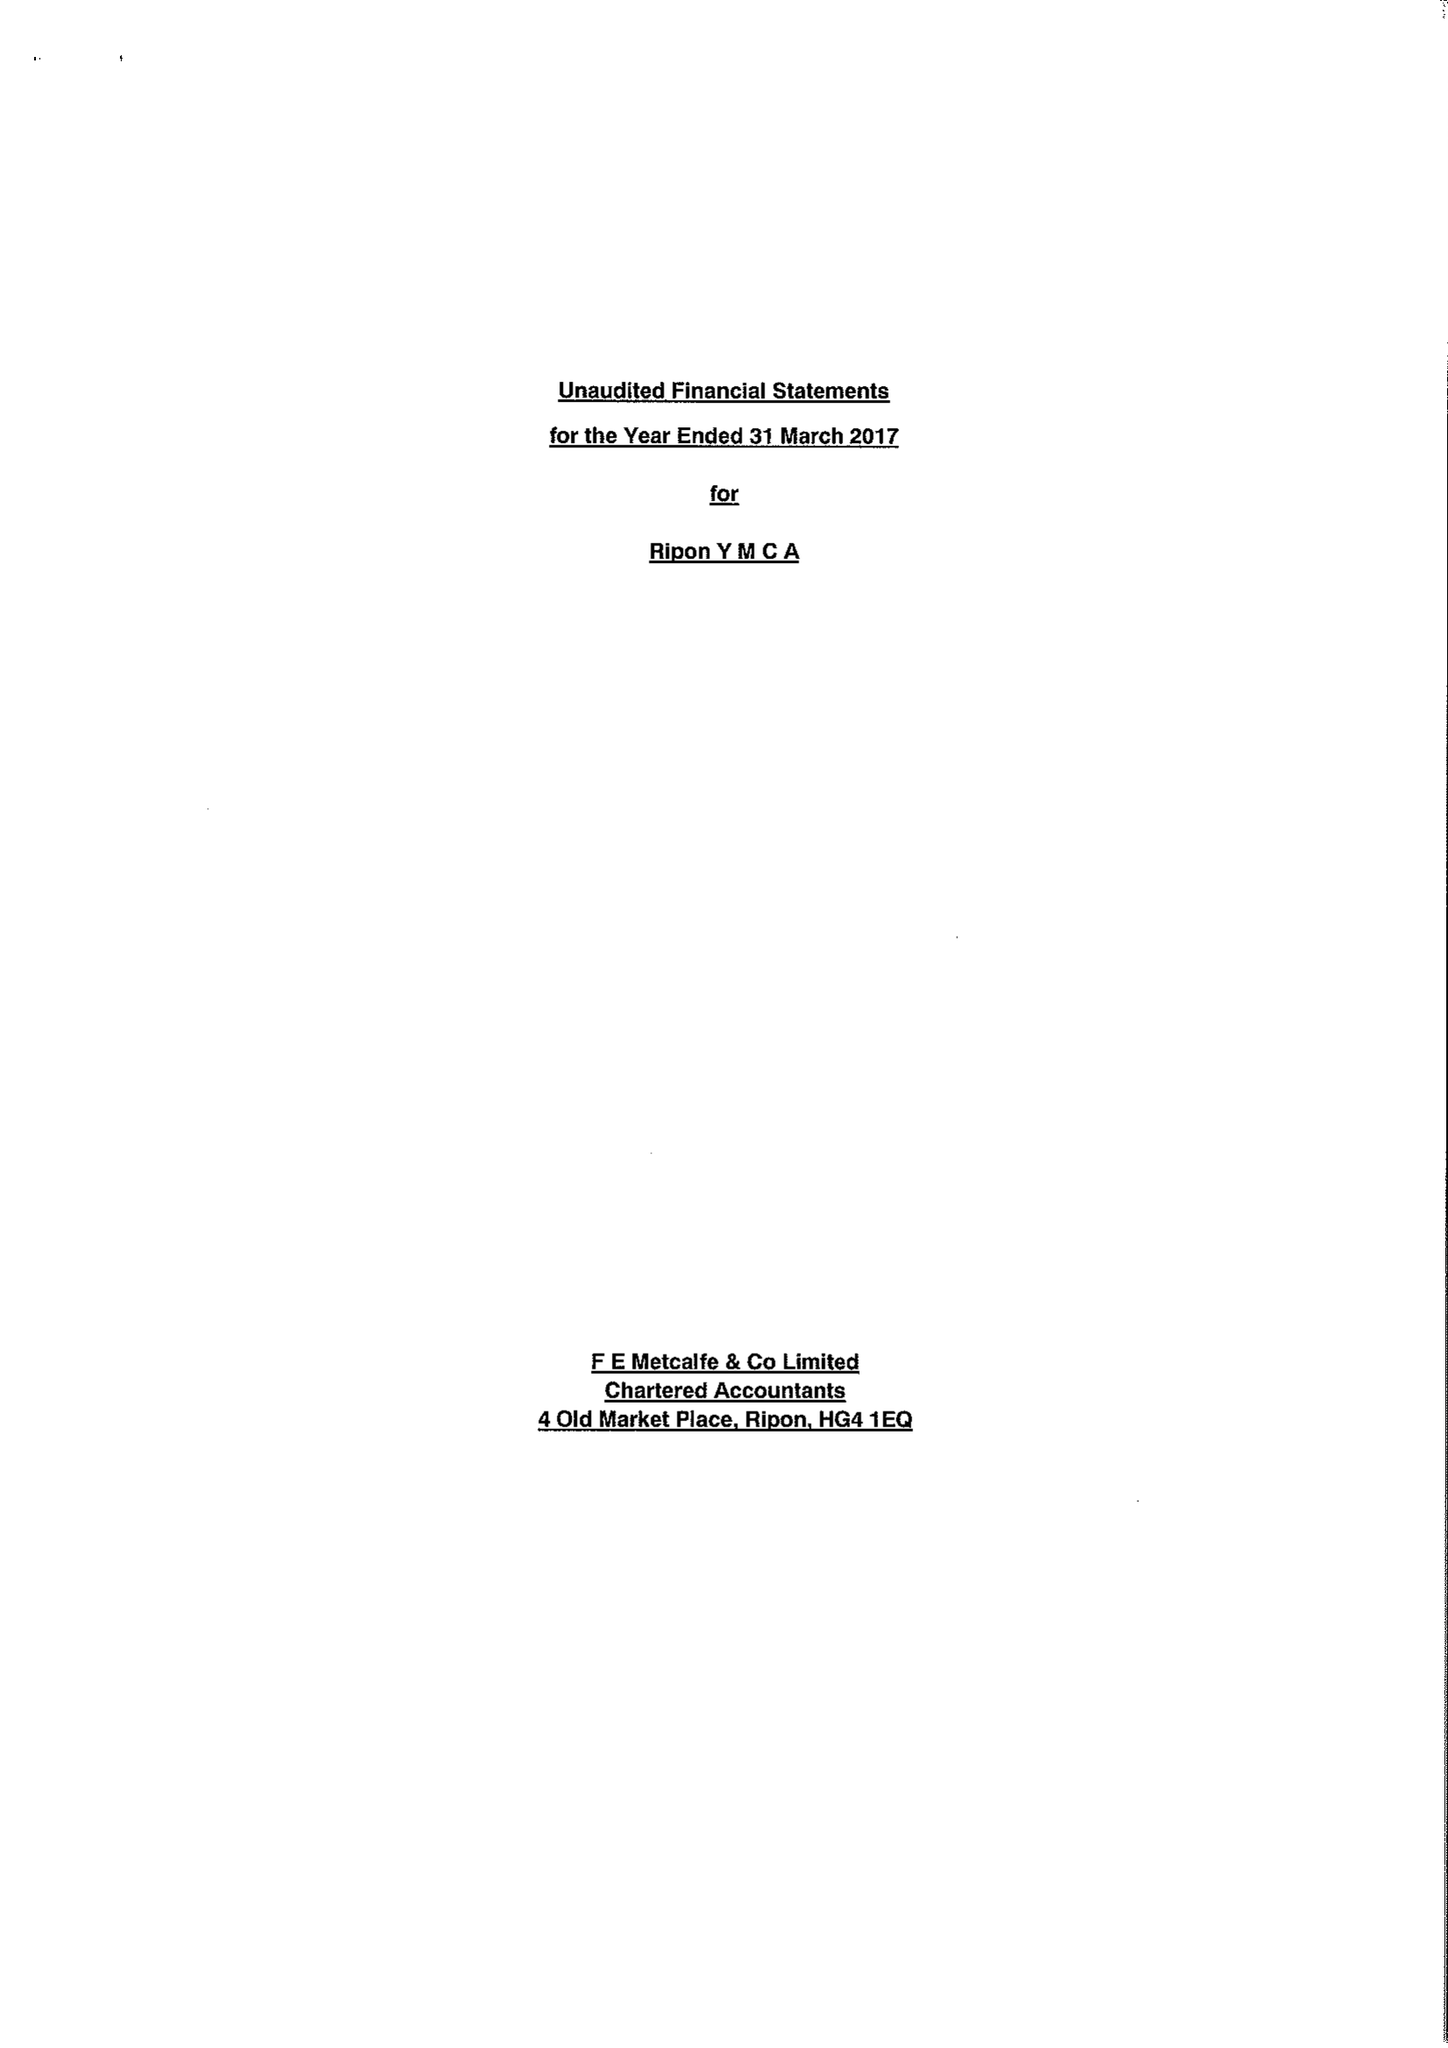What is the value for the income_annually_in_british_pounds?
Answer the question using a single word or phrase. 105843.00 